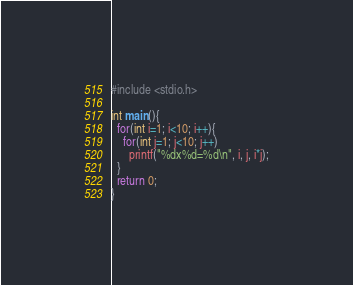<code> <loc_0><loc_0><loc_500><loc_500><_C_>#include <stdio.h>
   
int main(){
  for(int i=1; i<10; i++){
    for(int j=1; j<10; j++)
      printf("%dx%d=%d\n", i, j, i*j);
  }
  return 0;
}
</code> 